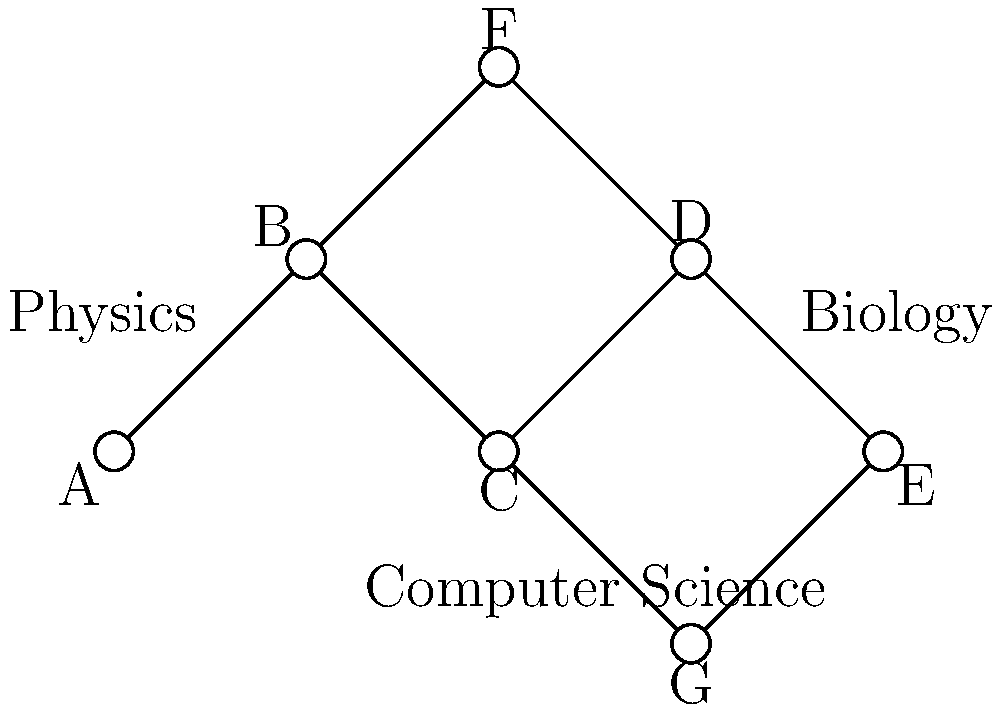In the given citation network graph representing interdisciplinary connections, how many communities can be identified using the Girvan-Newman algorithm, and what does this reveal about the structure of scientific collaboration in this network? To answer this question, let's apply the Girvan-Newman algorithm step-by-step:

1. The Girvan-Newman algorithm identifies communities by progressively removing edges with the highest betweenness centrality.

2. In this graph, we can observe three main clusters:
   - Vertices A and B (labeled as Physics)
   - Vertices D and E (labeled as Biology)
   - Vertices C and G (labeled as Computer Science)

3. Vertex F acts as a bridge between Physics and Biology communities.

4. To apply the algorithm:
   a) Calculate edge betweenness for all edges.
   b) Remove the edge with the highest betweenness.
   c) Recalculate betweenness for remaining edges.
   d) Repeat until the desired number of communities is reached.

5. The edges connecting F to B and D would likely have the highest betweenness, as they bridge between communities.

6. After removing these high betweenness edges, we are left with three distinct communities.

7. This reveals that the scientific collaboration in this network is structured around three main disciplines: Physics, Biology, and Computer Science.

8. The presence of vertex F and its connections suggest interdisciplinary work bridging Physics and Biology.

9. The structure indicates a balance between specialization (distinct communities) and interdisciplinary collaboration (bridging vertices).

This analysis demonstrates how the Girvan-Newman algorithm can be used to detect communities in citation networks, providing insights into the structure of scientific collaboration and interdisciplinary connections.
Answer: 3 communities: Physics, Biology, and Computer Science, revealing specialized clusters with interdisciplinary bridges. 